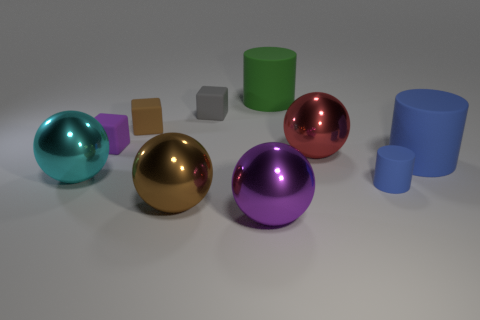Subtract all big brown spheres. How many spheres are left? 3 Subtract all blocks. How many objects are left? 7 Subtract all purple balls. How many balls are left? 3 Subtract 1 blocks. How many blocks are left? 2 Subtract all brown cylinders. Subtract all yellow cubes. How many cylinders are left? 3 Subtract all blue blocks. How many cyan balls are left? 1 Subtract all brown matte cubes. Subtract all purple balls. How many objects are left? 8 Add 2 big purple spheres. How many big purple spheres are left? 3 Add 2 small purple things. How many small purple things exist? 3 Subtract 1 brown cubes. How many objects are left? 9 